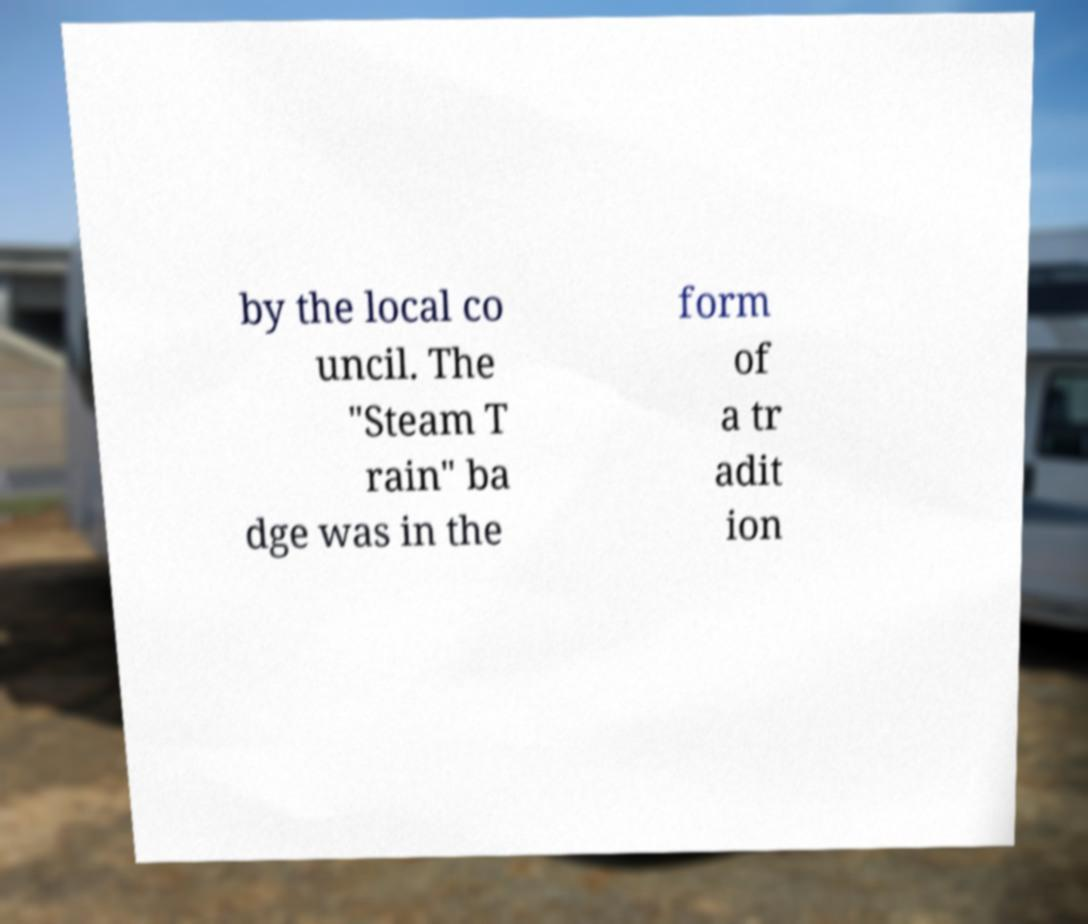There's text embedded in this image that I need extracted. Can you transcribe it verbatim? by the local co uncil. The "Steam T rain" ba dge was in the form of a tr adit ion 